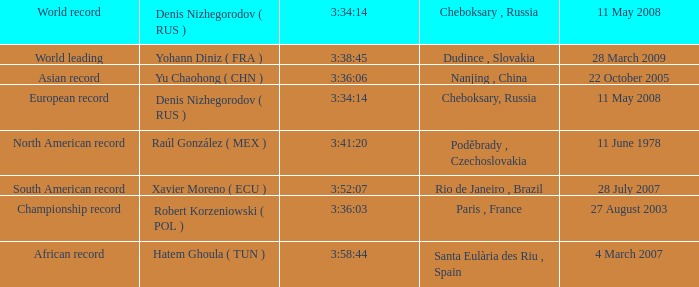When 3:38:45 is  3:34:14 what is the date on May 11th, 2008? 28 March 2009. 